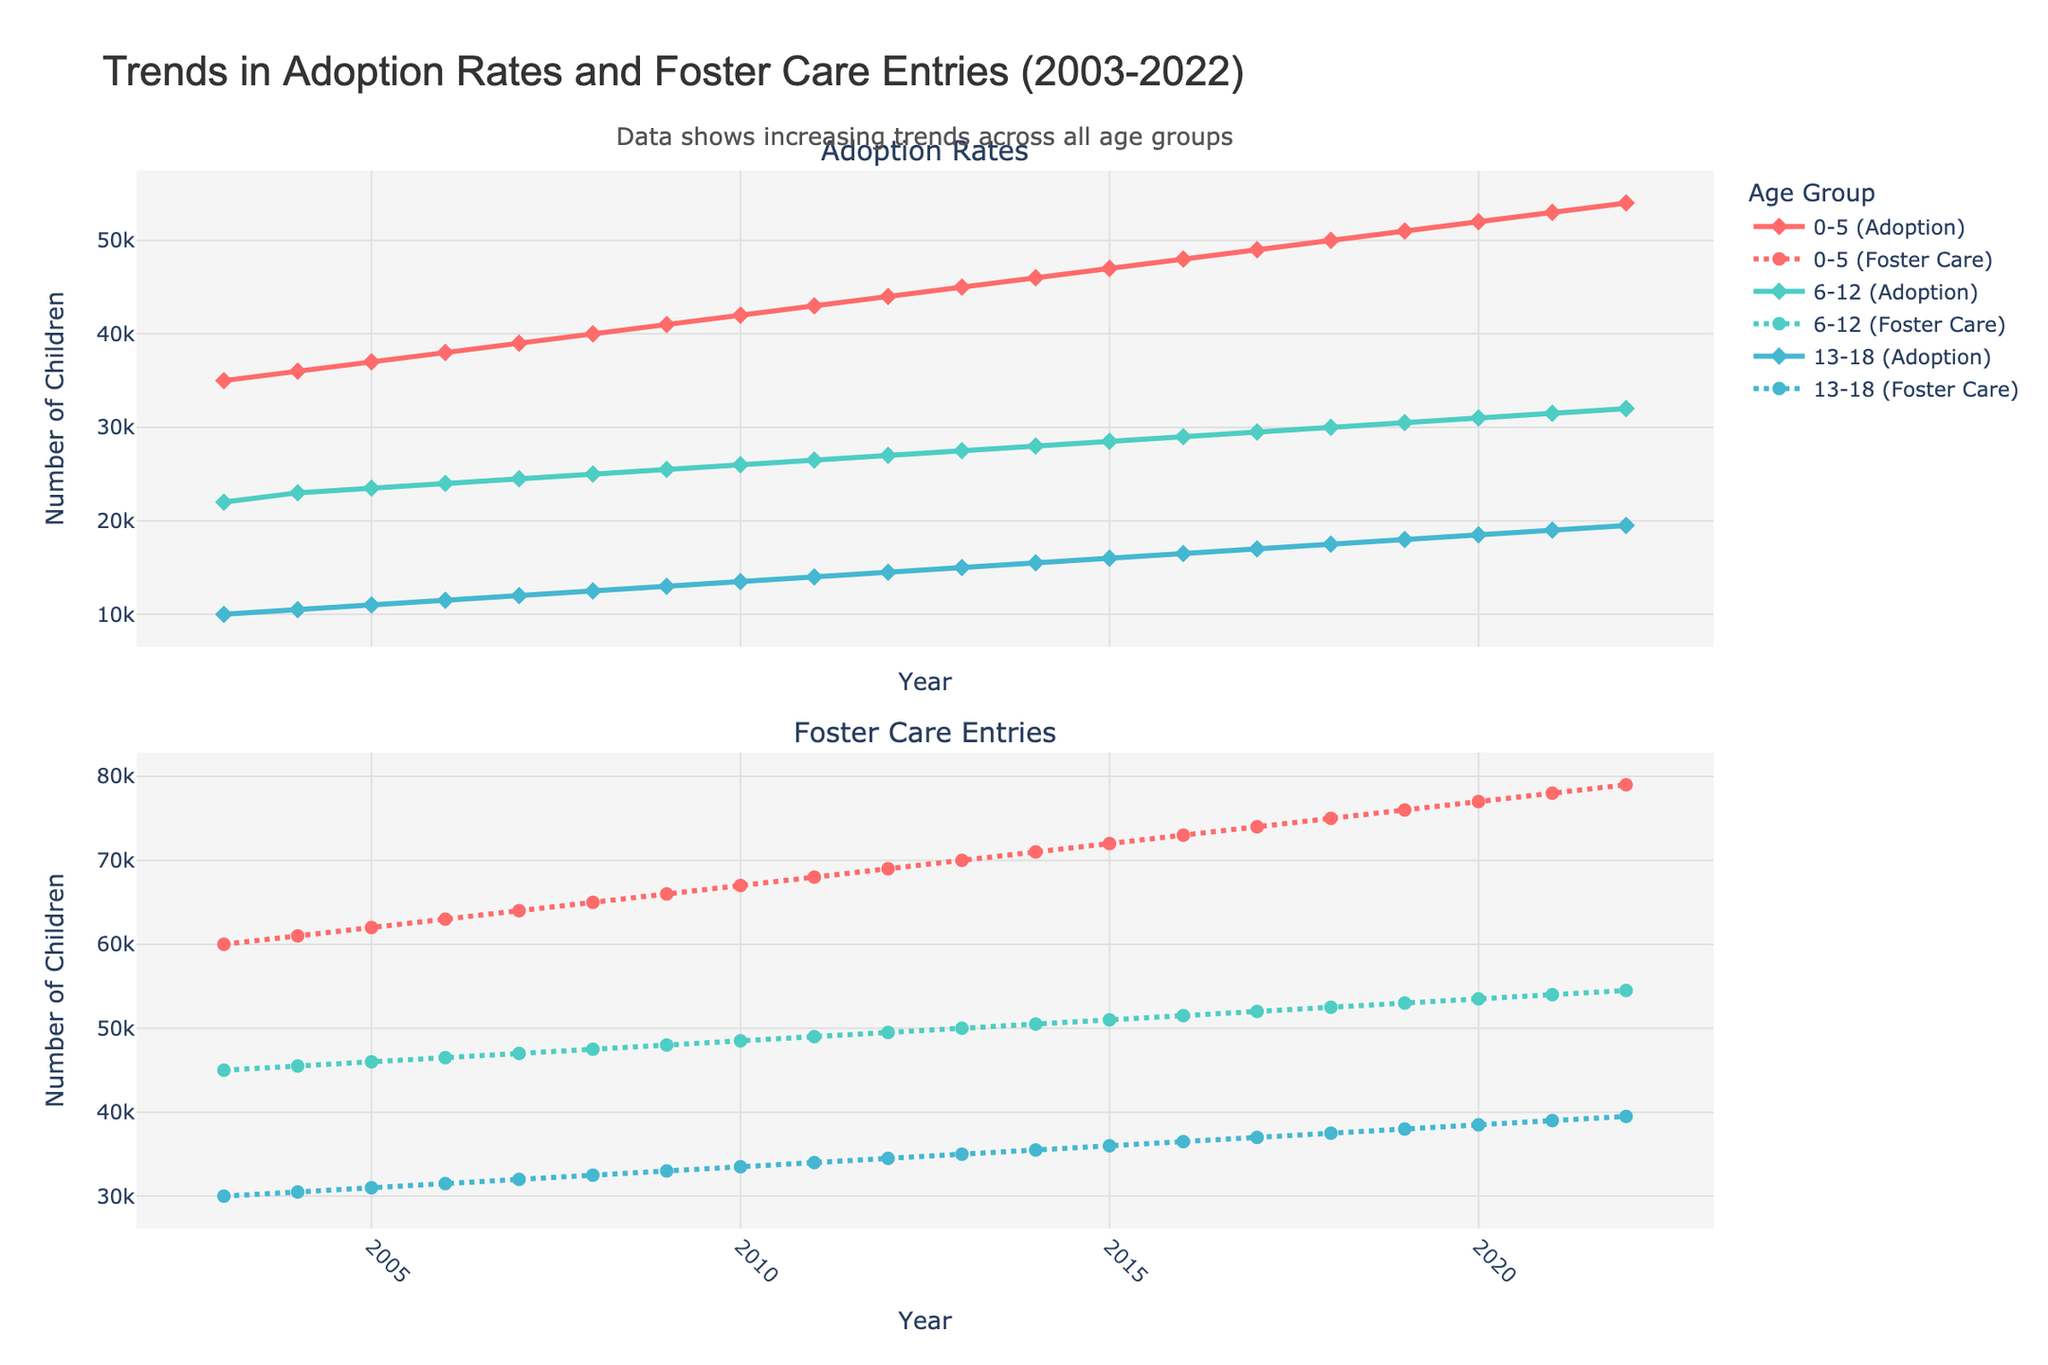What's the main title of the plot? The main title is usually placed at the top center of the figure and summarizes the information being displayed. In this case, it reads 'Trends in Adoption Rates and Foster Care Entries (2003-2022)'.
Answer: Trends in Adoption Rates and Foster Care Entries (2003-2022) What trends can be observed in the adoption rates for the 0-5 age group over the years? Observing the part of the plot related to the adoption rates for the 0-5 age group reveals a consistent increase in the number of adoptions over the years from 35,000 in 2003 to 54,000 in 2022.
Answer: Increasing Which age group had the highest number of foster care entries in 2022? Referring to the plot for 2022 data and looking at the foster care entries section, the 0-5 age group had the highest number of entries, with 79,000 entries.
Answer: 0-5 age group Between 2003 and 2022, which age group showed the most significant increase in adoption rates? By comparing the adoption rate lines for all age groups from 2003 to 2022, the 0-5 age group starts at 35,000 and ends at 54,000, marking an increase of 19,000. The other groups show a smaller increase, thus making the 0-5 age group the one with the most significant rise.
Answer: 0-5 age group How did the foster care entries for the 6-12 age group in 2021 compare to those in 2003? Locate the data points for the 6-12 age group in 2003 and 2021 on the foster care entries section of the plot. In 2003, there were 45,000 entries, while in 2021, there were 54,000 entries. This shows an increase of 9,000.
Answer: Increased by 9,000 Are there any annotations or notes on the plot? If so, what do they convey? Look for any text that stands out or is separate from the legend and axes, often to clarify a part of the data. There's an annotation at the top of the plot that mentions, 'Data shows increasing trends across all age groups.'
Answer: Data shows increasing trends across all age groups Which age group had the smallest increase in foster care entries from 2003 to 2022? By comparing the foster care entry lines from 2003 to 2022 for all age groups, the 13-18 age group starts at 30,000 and ends at 39,500, marking an increase of 9,500. This is the smallest increase compared to the other two age groups.
Answer: 13-18 age group 